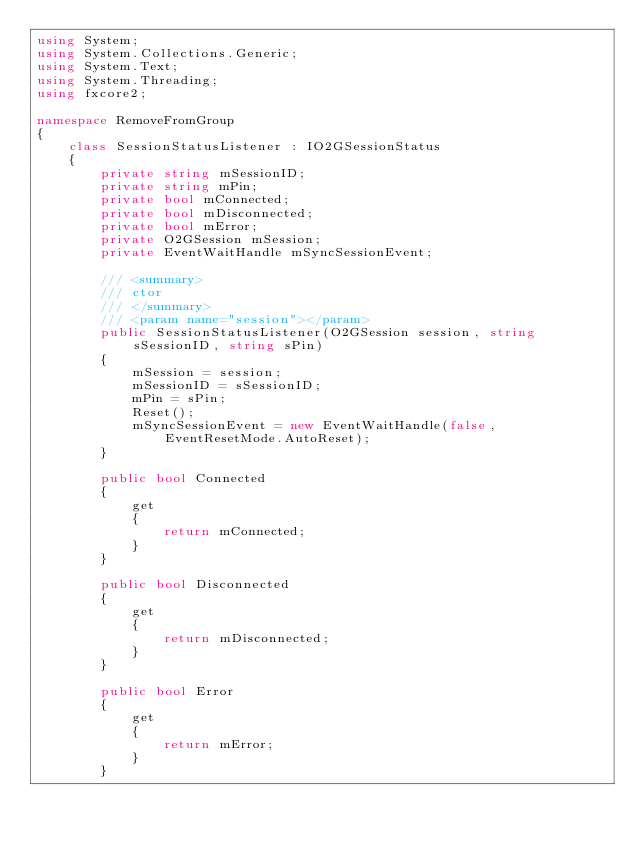Convert code to text. <code><loc_0><loc_0><loc_500><loc_500><_C#_>using System;
using System.Collections.Generic;
using System.Text;
using System.Threading;
using fxcore2;

namespace RemoveFromGroup
{
    class SessionStatusListener : IO2GSessionStatus
    {
        private string mSessionID;
        private string mPin;
        private bool mConnected;
        private bool mDisconnected;
        private bool mError;
        private O2GSession mSession;
        private EventWaitHandle mSyncSessionEvent;

        /// <summary>
        /// ctor
        /// </summary>
        /// <param name="session"></param>
        public SessionStatusListener(O2GSession session, string sSessionID, string sPin)
        {
            mSession = session;
            mSessionID = sSessionID;
            mPin = sPin;
            Reset();
            mSyncSessionEvent = new EventWaitHandle(false, EventResetMode.AutoReset);
        }

        public bool Connected
        {
            get
            {
                return mConnected;
            }
        }

        public bool Disconnected
        {
            get
            {
                return mDisconnected;
            }
        }

        public bool Error
        {
            get
            {
                return mError;
            }
        }
</code> 